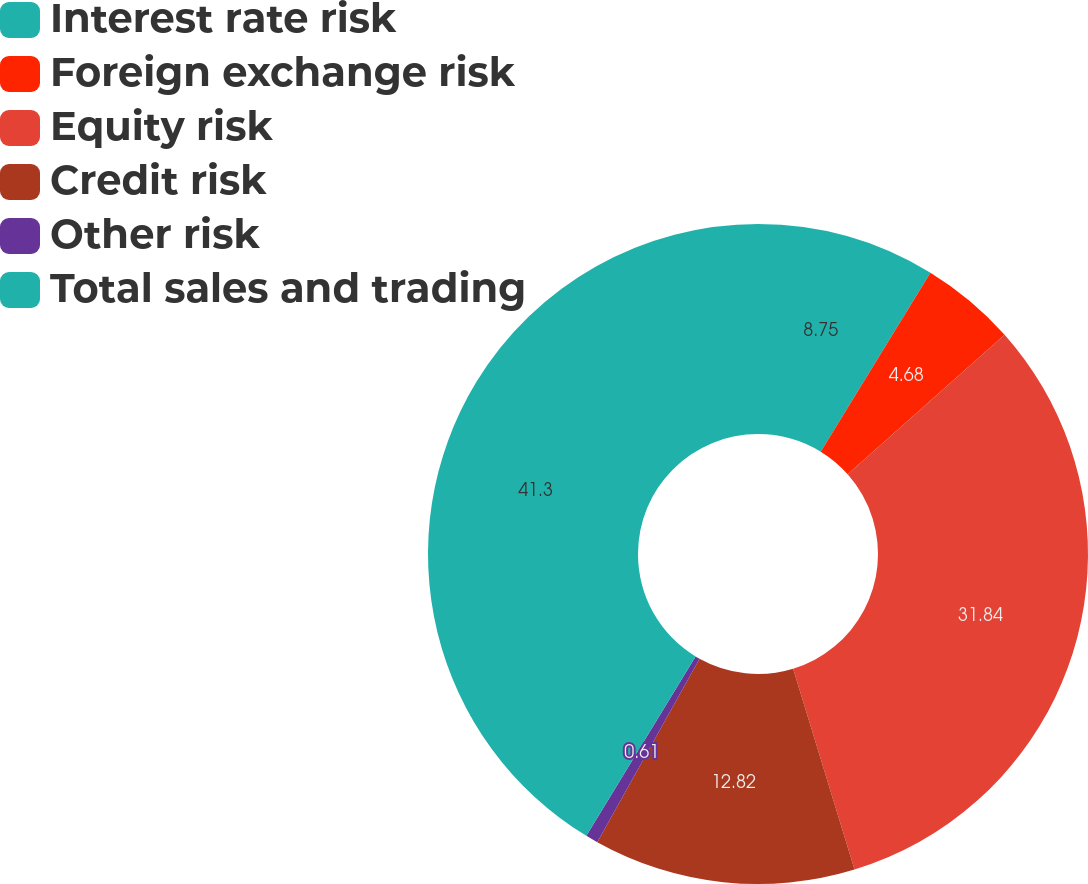Convert chart. <chart><loc_0><loc_0><loc_500><loc_500><pie_chart><fcel>Interest rate risk<fcel>Foreign exchange risk<fcel>Equity risk<fcel>Credit risk<fcel>Other risk<fcel>Total sales and trading<nl><fcel>8.75%<fcel>4.68%<fcel>31.84%<fcel>12.82%<fcel>0.61%<fcel>41.29%<nl></chart> 